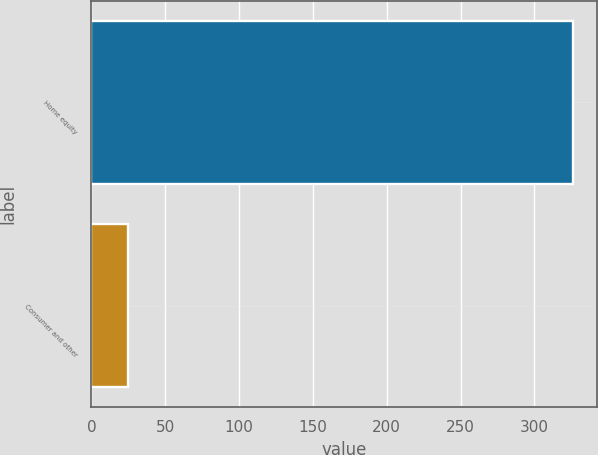Convert chart. <chart><loc_0><loc_0><loc_500><loc_500><bar_chart><fcel>Home equity<fcel>Consumer and other<nl><fcel>326.1<fcel>24.7<nl></chart> 